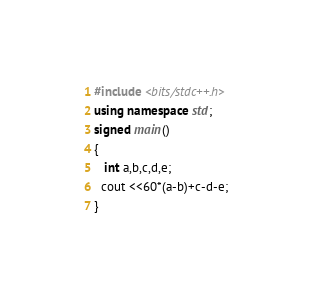Convert code to text. <code><loc_0><loc_0><loc_500><loc_500><_C++_>#include <bits/stdc++.h>
using namespace std;
signed main()
{
   int a,b,c,d,e;
  cout <<60*(a-b)+c-d-e;
}
</code> 